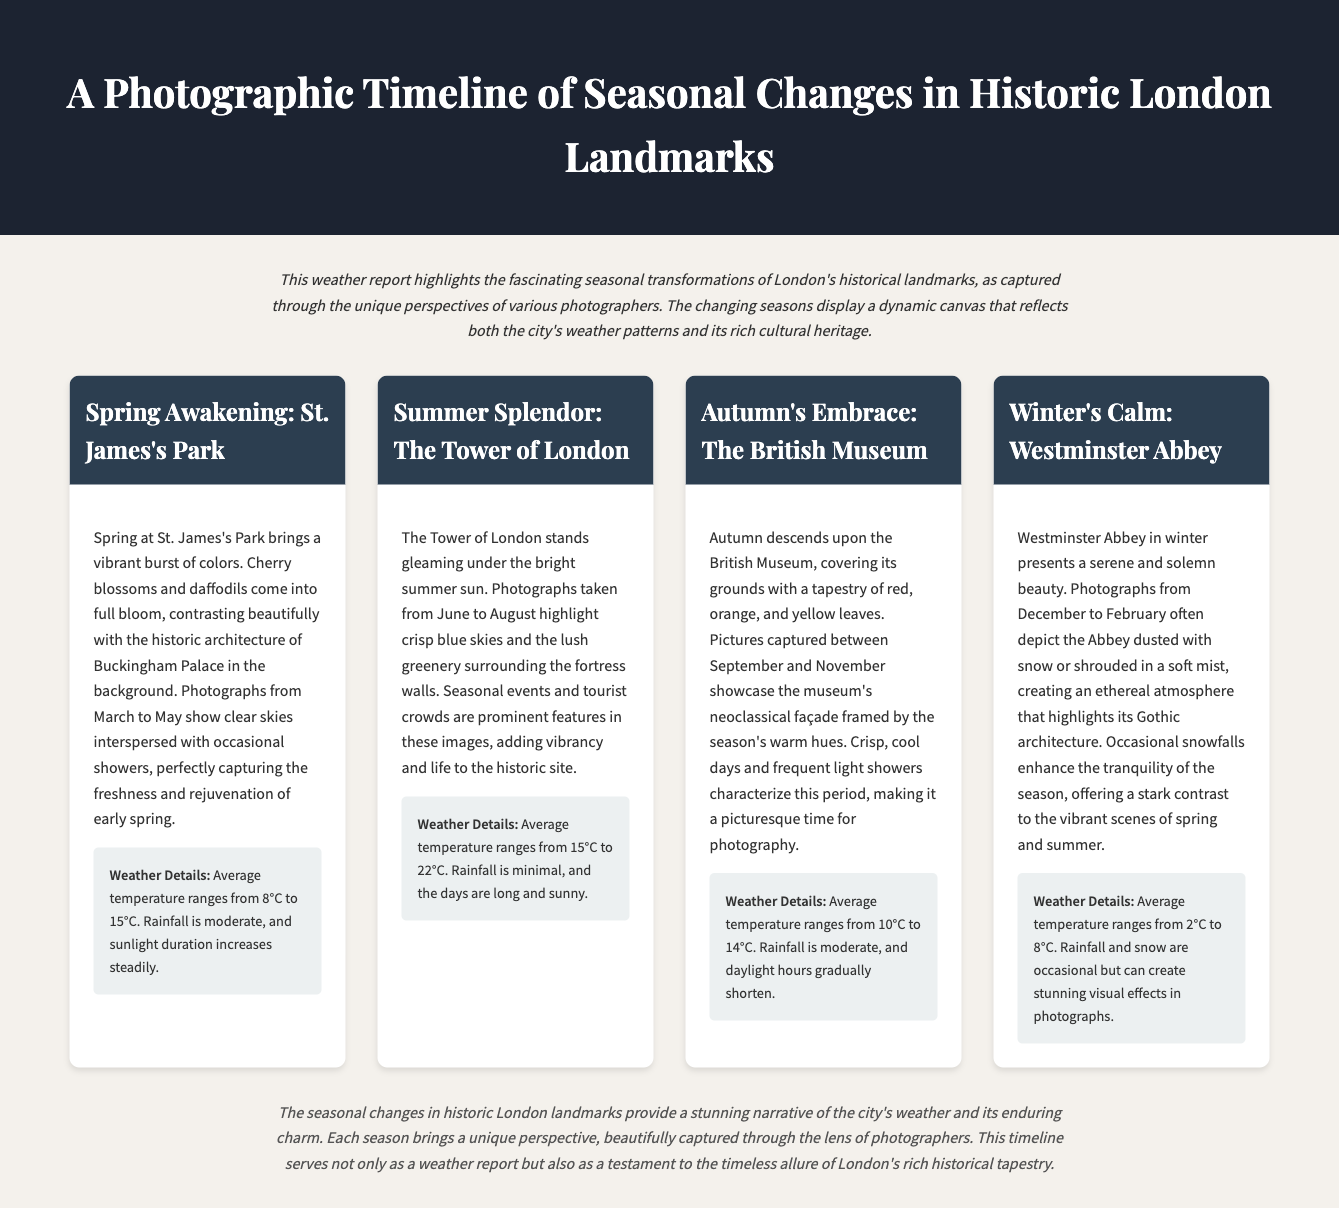What is the title of the document? The title is specified in the header section of the document.
Answer: A Photographic Timeline of Seasonal Changes in Historic London Landmarks What is the average temperature range in spring? The average temperature range for spring is mentioned under the weather details for St. James's Park.
Answer: 8°C to 15°C Which landmark is highlighted for summer? The landmark discussed in the summer section is explicitly stated in the title of the summer card.
Answer: The Tower of London What colors are associated with autumn at the British Museum? The colors are listed in the description under the autumn section.
Answer: Red, orange, and yellow What is the average temperature range in winter? The winter average temperature range is provided in the weather details for Westminster Abbey.
Answer: 2°C to 8°C How does the weather in autumn affect photography? This reasoning is derived from the description of autumn's characteristics impacting photographic conditions.
Answer: Crisp, cool days and frequent light showers What season captures the vibrant colors of St. James's Park? This information is directly related to the seasonal changes described in that section of the document.
Answer: Spring What weather phenomenon enhances tranquility in winter? The specific weather phenomenon considered affects the atmosphere described under winter.
Answer: Occasional snowfalls 